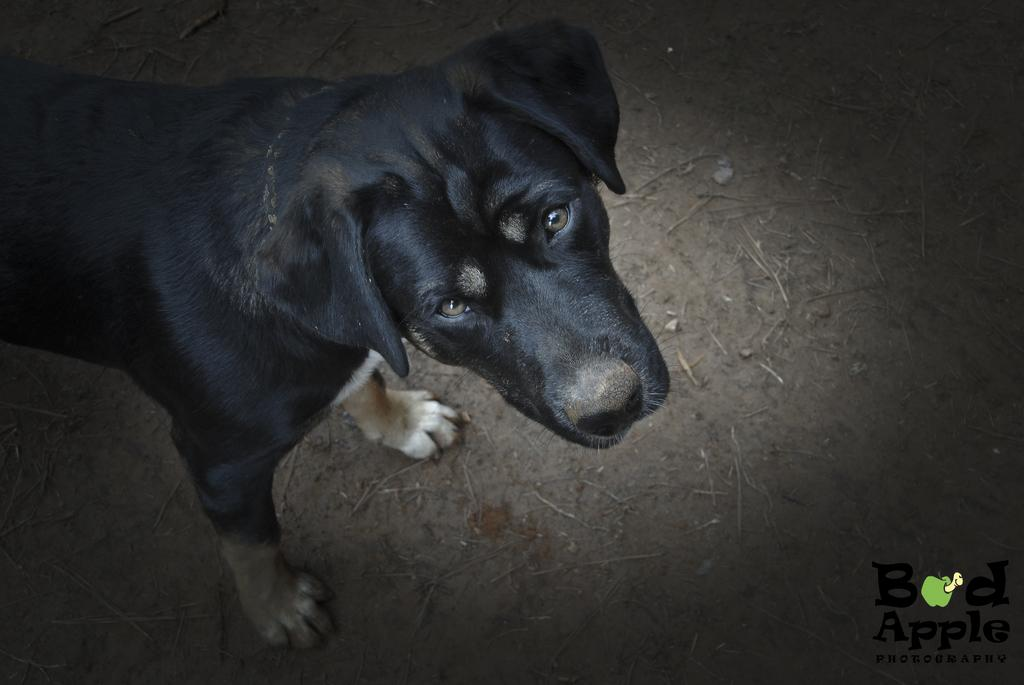What type of animal is in the image? There is a black color dog in the image. Where is the dog located in the image? The dog is on the ground. What else can be seen on the ground in the image? There are small sticks on the ground. Is there any text or marking in the image? Yes, there is a watermark in the bottom right corner of the image. Is the dog wearing a scarf in the image? There is no mention of a scarf in the image, so it cannot be determined if the dog is wearing one. 